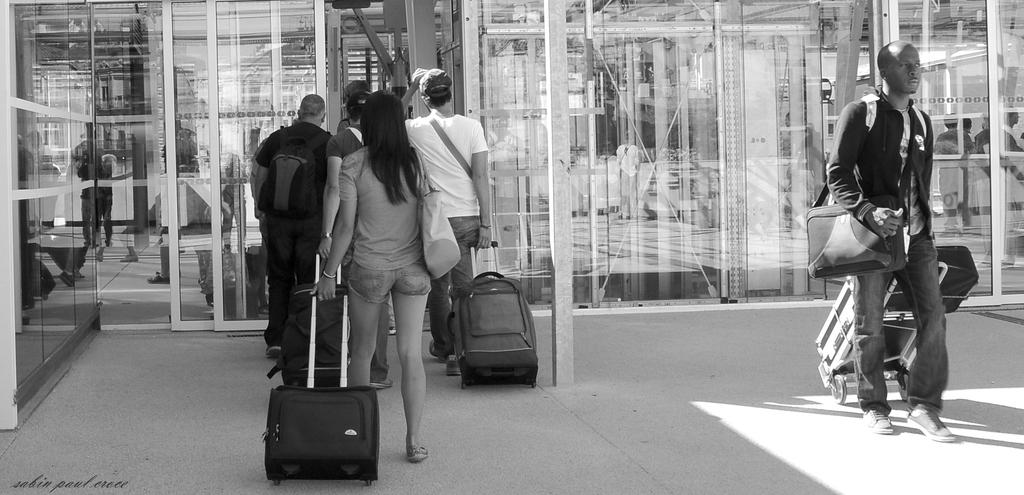What are the people in the image doing? The people in the image are walking in the road. What are the people carrying while walking? The people are carrying luggage bags in their hands. What can be seen in the background of the image? There are glass doors in the background. What is happening behind the glass doors? There are people behind the glass doors. Can you tell me the route the giraffe is taking in the image? There is no giraffe present in the image, so it is not possible to determine the route it might be taking. 